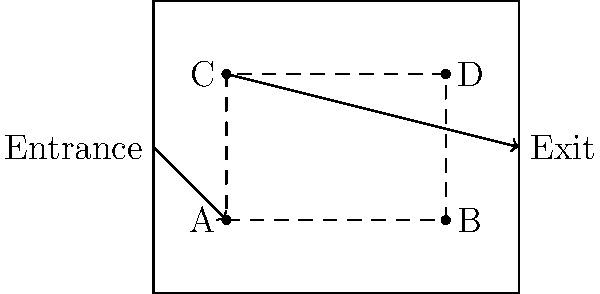As a budget-conscious mother planning an educational family outing, you're organizing a museum tour. Given the simple floor plan above, what is the most efficient route to visit all exhibits (A, B, C, and D) exactly once, starting from the entrance and ending at the exit? To find the most efficient route, we need to consider the following steps:

1. We must start at the entrance and end at the exit.
2. We need to visit all exhibits (A, B, C, and D) exactly once.
3. The most efficient route will minimize the total distance traveled.

Let's analyze the possible routes:

1. Entrance → A → B → D → C → Exit
   This route follows a logical clockwise path through all exhibits.

2. Entrance → A → C → D → B → Exit
   This route requires backtracking, which is less efficient.

3. Entrance → C → D → B → A → Exit
   This route also requires backtracking and is less efficient.

4. Entrance → C → A → B → D → Exit
   This route involves unnecessary zigzagging between exhibits.

The most efficient route is option 1: Entrance → A → B → D → C → Exit

This route:
- Starts at the entrance
- Visits all exhibits in a logical order without backtracking
- Ends at the exit
- Minimizes the total distance traveled

By following this path, you ensure that your family visits all exhibits efficiently, maximizing educational value while minimizing time and energy spent walking – perfect for a frugal and organized family outing.
Answer: Entrance → A → B → D → C → Exit 